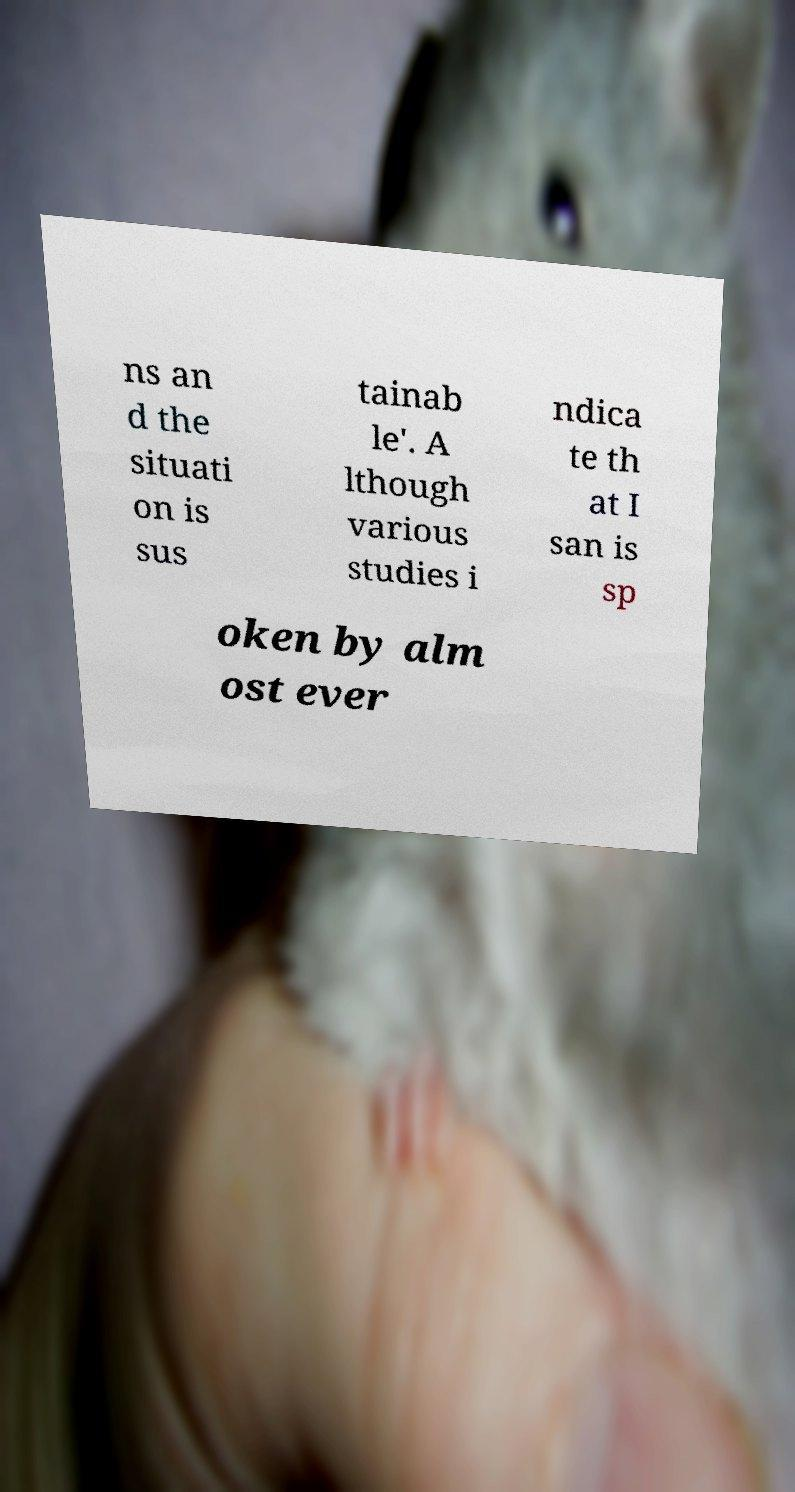There's text embedded in this image that I need extracted. Can you transcribe it verbatim? ns an d the situati on is sus tainab le'. A lthough various studies i ndica te th at I san is sp oken by alm ost ever 